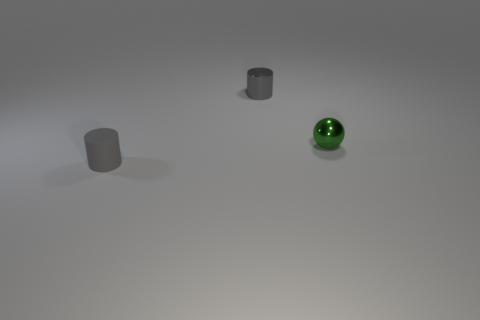Are there more gray metallic cylinders than purple rubber cubes?
Ensure brevity in your answer.  Yes. There is a gray thing that is in front of the small cylinder behind the green object; are there any tiny rubber things to the left of it?
Make the answer very short. No. How many other things are the same size as the gray metallic thing?
Provide a short and direct response. 2. There is a tiny rubber cylinder; are there any small shiny spheres in front of it?
Provide a succinct answer. No. Is the color of the shiny cylinder the same as the cylinder to the left of the tiny gray shiny thing?
Offer a terse response. Yes. There is a object that is in front of the tiny shiny object that is in front of the small metallic thing behind the green metal object; what is its color?
Your answer should be very brief. Gray. Are there any other gray things of the same shape as the gray matte object?
Provide a short and direct response. Yes. What is the color of the cylinder that is the same size as the gray metallic object?
Your answer should be compact. Gray. There is a cylinder right of the small matte cylinder; what is it made of?
Give a very brief answer. Metal. There is a gray thing on the left side of the small shiny cylinder; is it the same shape as the gray thing that is behind the green sphere?
Keep it short and to the point. Yes. 